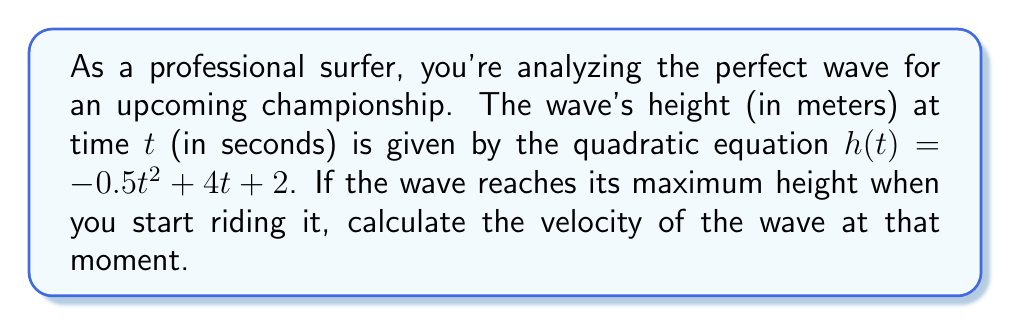Help me with this question. 1) To find the maximum height of the wave, we need to find the vertex of the parabola. The vertex occurs at the axis of symmetry.

2) For a quadratic equation in the form $f(t) = at^2 + bt + c$, the t-coordinate of the vertex is given by $t = -\frac{b}{2a}$.

3) In our equation $h(t) = -0.5t^2 + 4t + 2$, we have $a = -0.5$ and $b = 4$.

4) Substituting these values:
   $t = -\frac{4}{2(-0.5)} = -\frac{4}{-1} = 4$

5) The wave reaches its maximum height at $t = 4$ seconds.

6) To find the velocity at this point, we need to take the derivative of $h(t)$ and evaluate it at $t = 4$.

7) The derivative of $h(t)$ is:
   $h'(t) = -t + 4$

8) This gives us the velocity function. Evaluating at $t = 4$:
   $h'(4) = -4 + 4 = 0$

9) The velocity at the maximum height is 0 m/s, which makes sense as the wave momentarily stops rising at its peak.
Answer: 0 m/s 